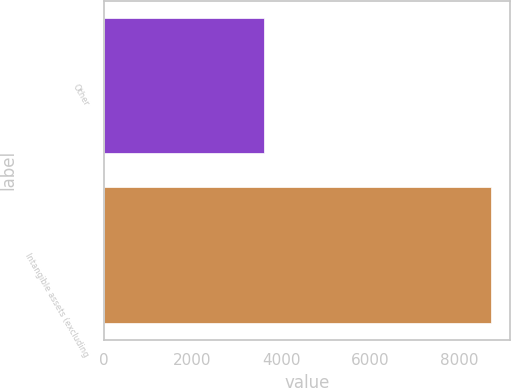Convert chart to OTSL. <chart><loc_0><loc_0><loc_500><loc_500><bar_chart><fcel>Other<fcel>Intangible assets (excluding<nl><fcel>3616<fcel>8714<nl></chart> 